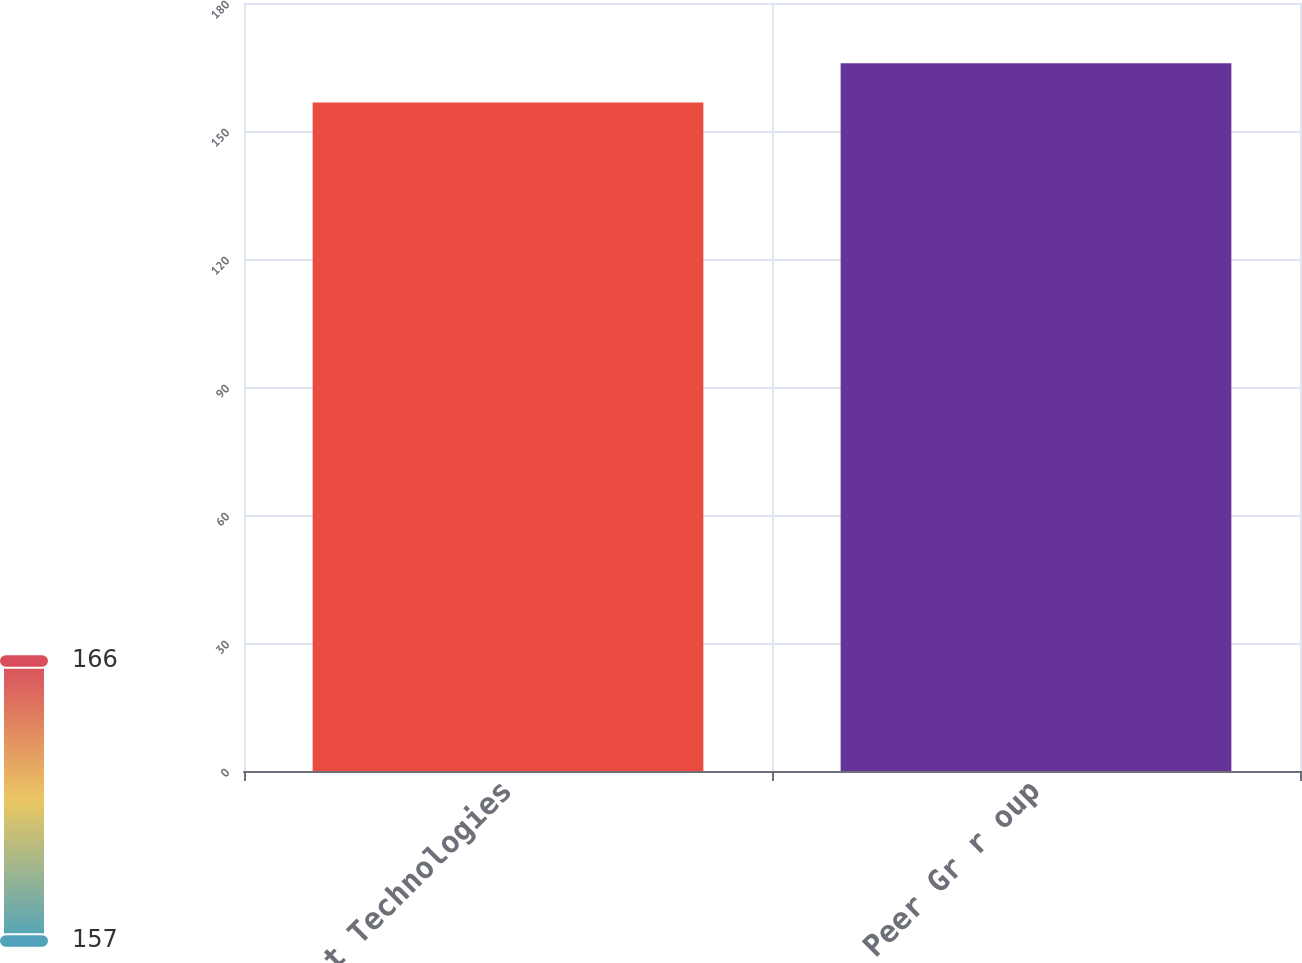<chart> <loc_0><loc_0><loc_500><loc_500><bar_chart><fcel>Agilent Technologies<fcel>Peer Gr r oup<nl><fcel>156.67<fcel>165.85<nl></chart> 